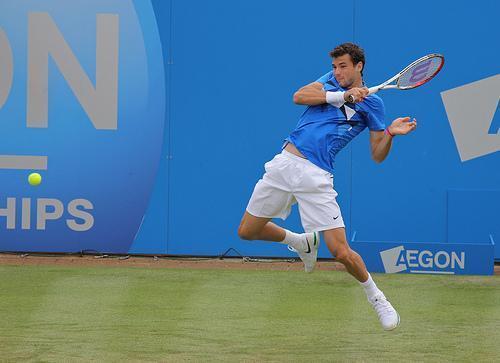How many players?
Give a very brief answer. 1. How many men have on white shorts?
Give a very brief answer. 1. 